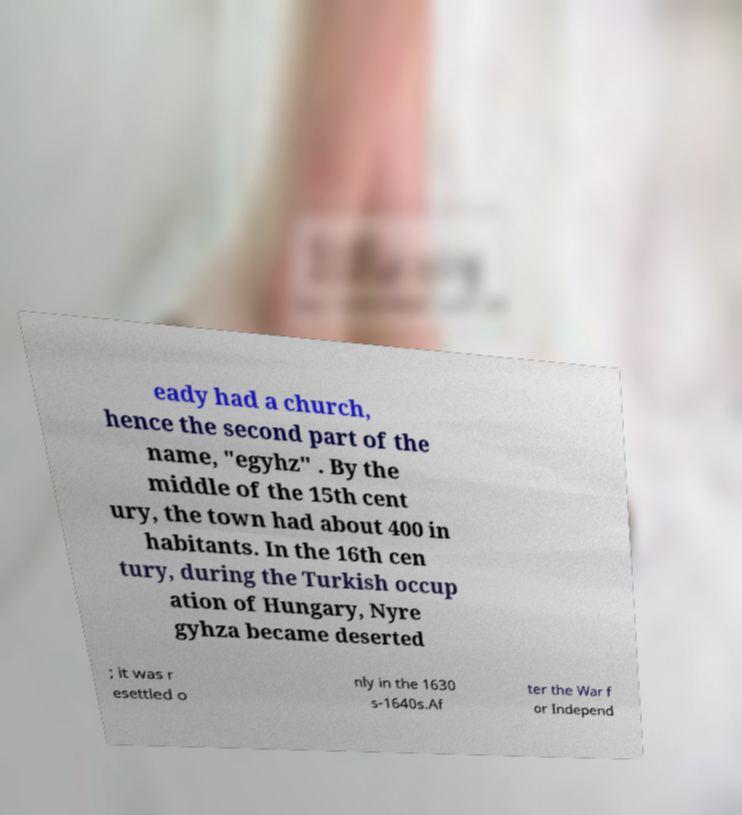For documentation purposes, I need the text within this image transcribed. Could you provide that? eady had a church, hence the second part of the name, "egyhz" . By the middle of the 15th cent ury, the town had about 400 in habitants. In the 16th cen tury, during the Turkish occup ation of Hungary, Nyre gyhza became deserted ; it was r esettled o nly in the 1630 s-1640s.Af ter the War f or Independ 